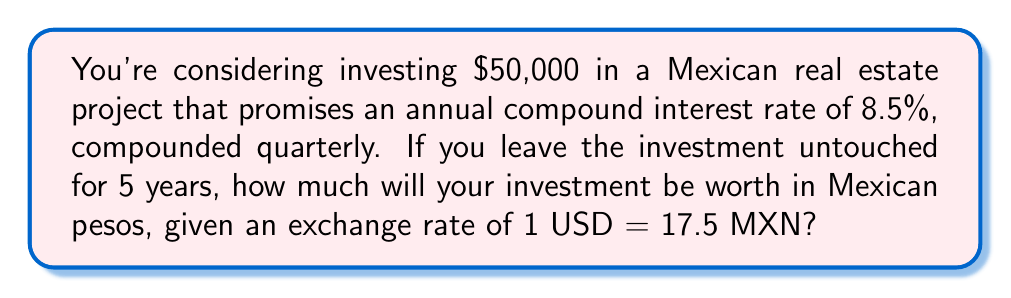Can you answer this question? Let's approach this step-by-step:

1) First, we need to use the compound interest formula:
   
   $A = P(1 + \frac{r}{n})^{nt}$

   Where:
   $A$ = final amount
   $P$ = principal (initial investment)
   $r$ = annual interest rate (as a decimal)
   $n$ = number of times interest is compounded per year
   $t$ = number of years

2) We have:
   $P = 50,000$
   $r = 0.085$ (8.5% as a decimal)
   $n = 4$ (compounded quarterly)
   $t = 5$ years

3) Let's plug these values into the formula:

   $A = 50,000(1 + \frac{0.085}{4})^{4(5)}$

4) Simplify:
   
   $A = 50,000(1 + 0.02125)^{20}$

5) Calculate:
   
   $A = 50,000(1.02125)^{20}$
   $A = 50,000(1.5181)$
   $A = 75,905$ USD

6) Now, we need to convert this to Mexican pesos:
   
   $75,905 \text{ USD} \times 17.5 \text{ MXN/USD} = 1,328,337.50 \text{ MXN}$

Therefore, after 5 years, the investment will be worth 1,328,337.50 Mexican pesos.
Answer: 1,328,337.50 MXN 